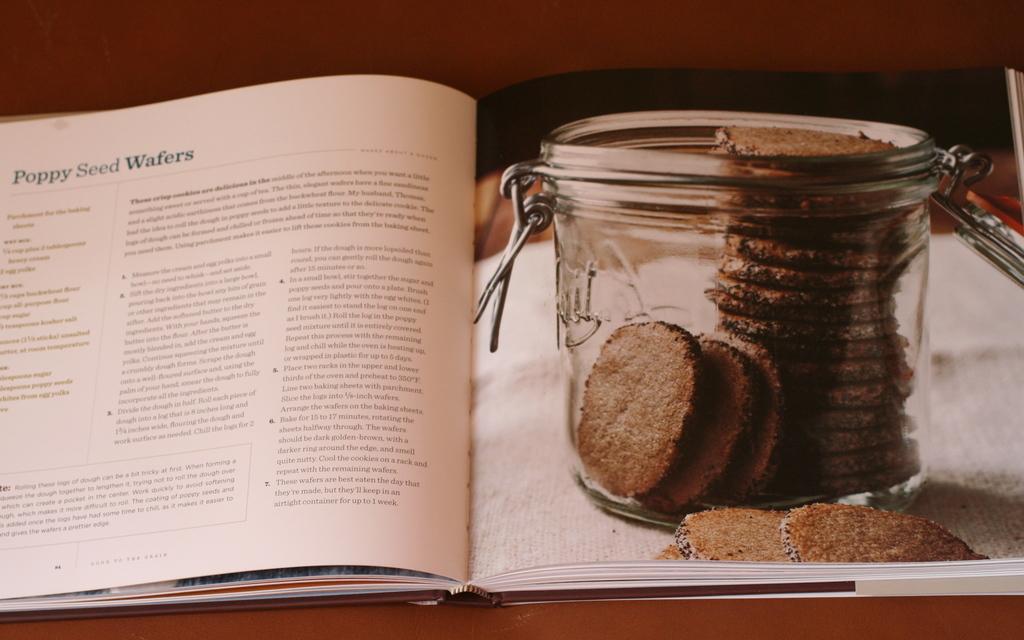What is the recipe on this page for?
Your response must be concise. Poppy seed wafers. What page number is this recipe located on?
Keep it short and to the point. 84. 